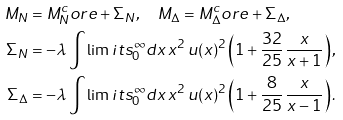<formula> <loc_0><loc_0><loc_500><loc_500>M _ { N } & = M _ { N } ^ { c } o r e + \Sigma _ { N } , \quad M _ { \Delta } = M _ { \Delta } ^ { c } o r e + \Sigma _ { \Delta } , \\ \Sigma _ { N } & = - \lambda \int \lim i t s _ { 0 } ^ { \infty } d x \, x ^ { 2 } \, u ( x ) ^ { 2 } \left ( 1 + \frac { 3 2 } { 2 5 } \, \frac { x } { x + 1 } \right ) , \\ \Sigma _ { \Delta } & = - \lambda \int \lim i t s _ { 0 } ^ { \infty } d x \, x ^ { 2 } \, u ( x ) ^ { 2 } \left ( 1 + \frac { 8 } { 2 5 } \, \frac { x } { x - 1 } \right ) .</formula> 